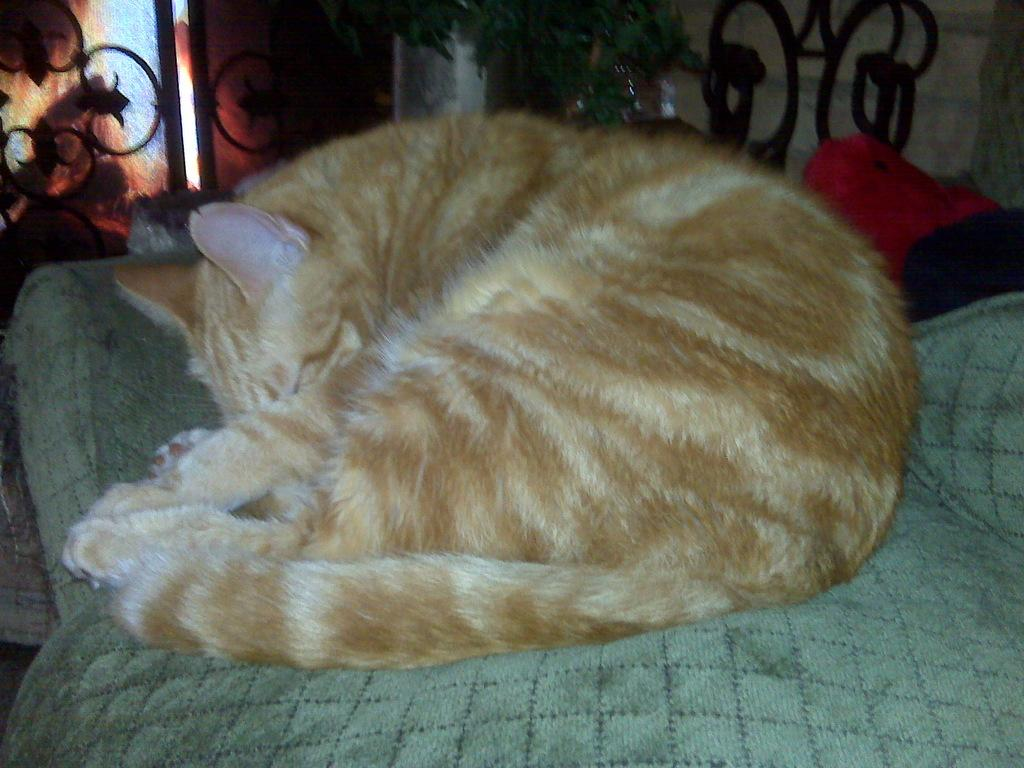What type of animal is in the image? There is a brown cat in the image. What is the cat doing in the image? The cat is lying on something. What can be seen in the background of the image? There are railings in the background of the image. What other living organism is present in the image? There is a plant in the image. What type of waves can be seen in the image? There are no waves present in the image. 